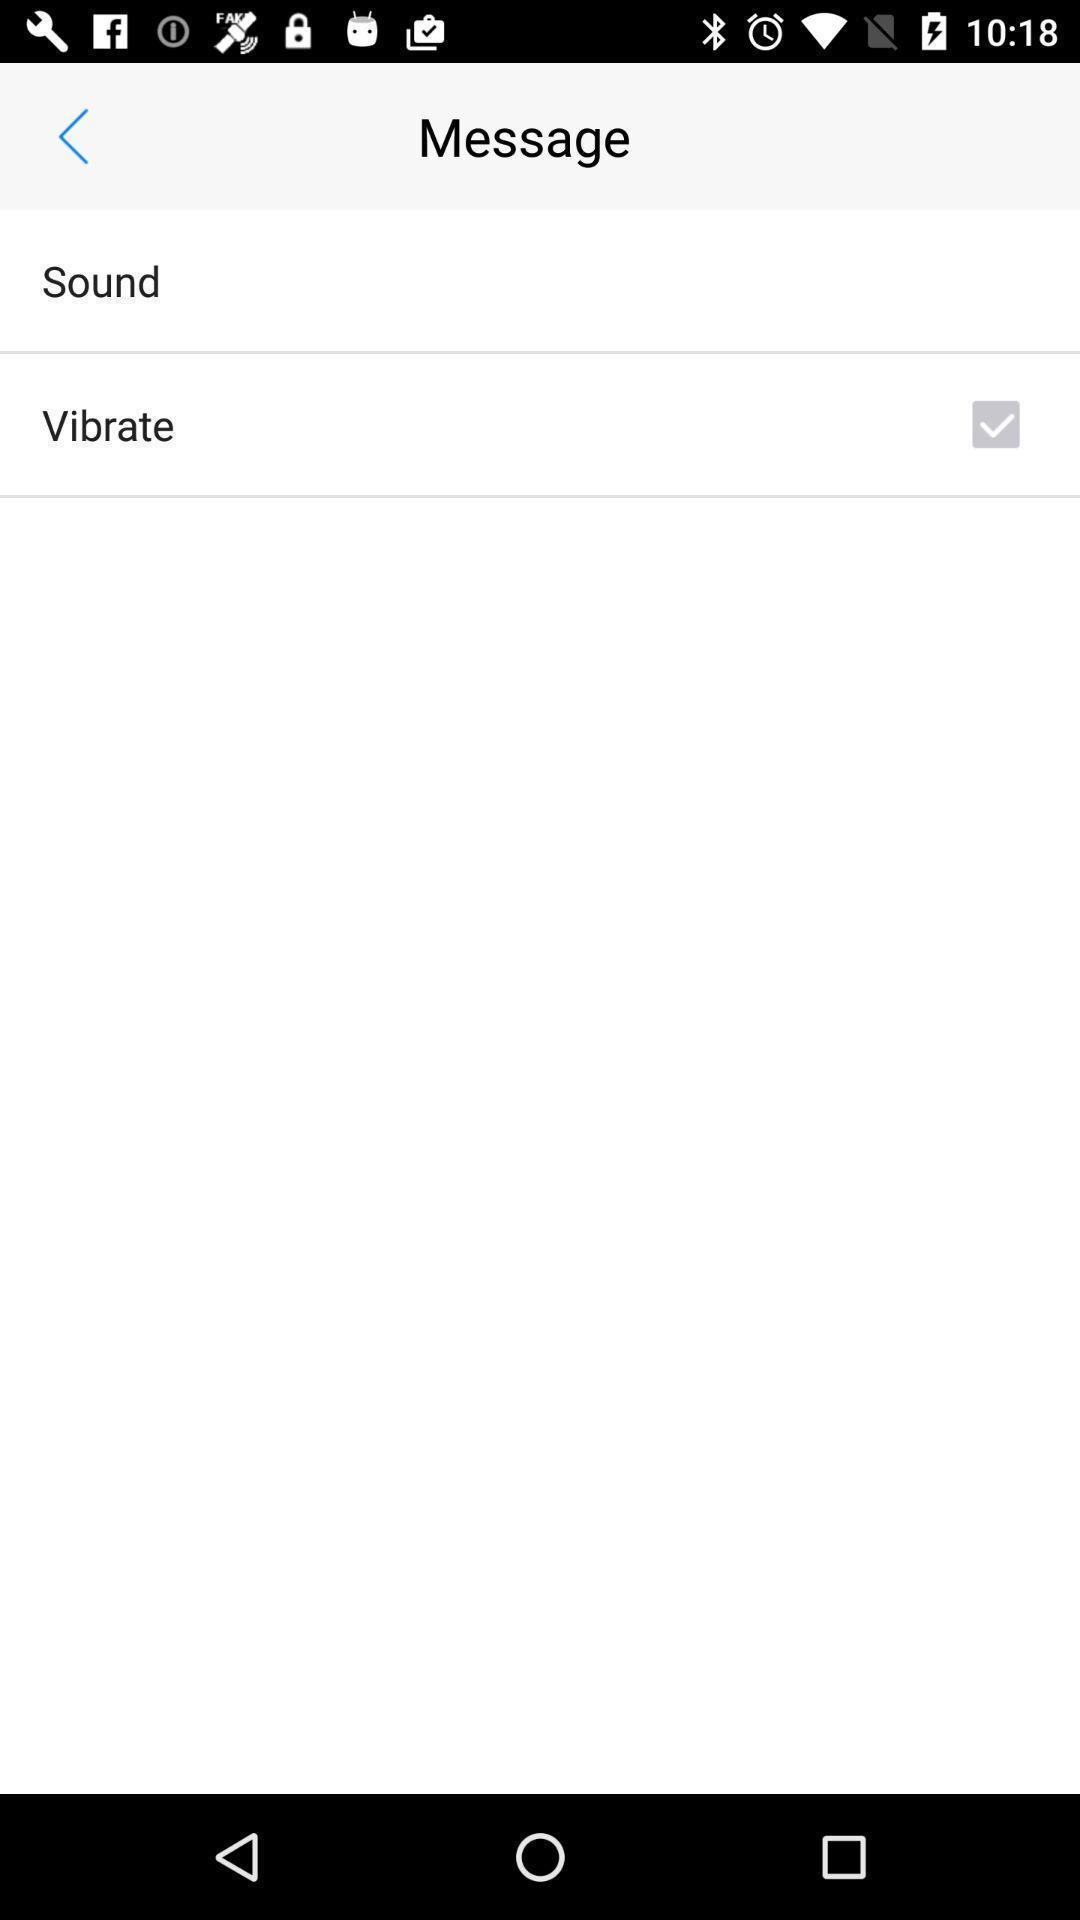Tell me about the visual elements in this screen capture. Sound options of sound in phone. 